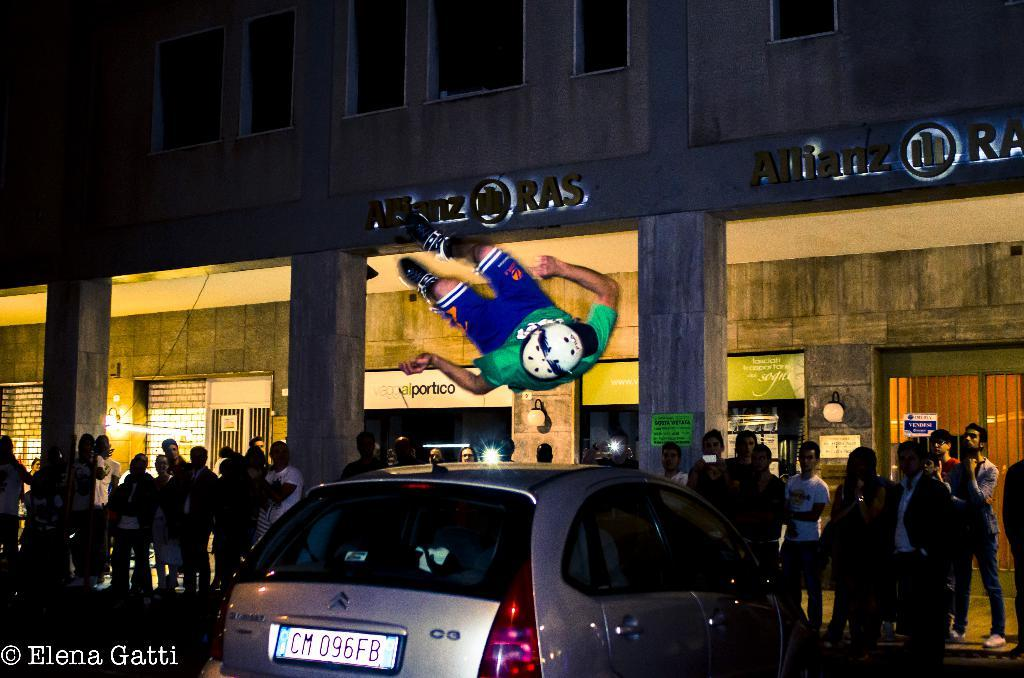What is the main subject of the image? The main subject of the image is a car. Are there any people present in the image? Yes, there are people standing in the image. What can be seen on the building in the image? There is a building with boards and text in the image. What type of powder is being used by the dad in the image? There is no dad or powder present in the image. 